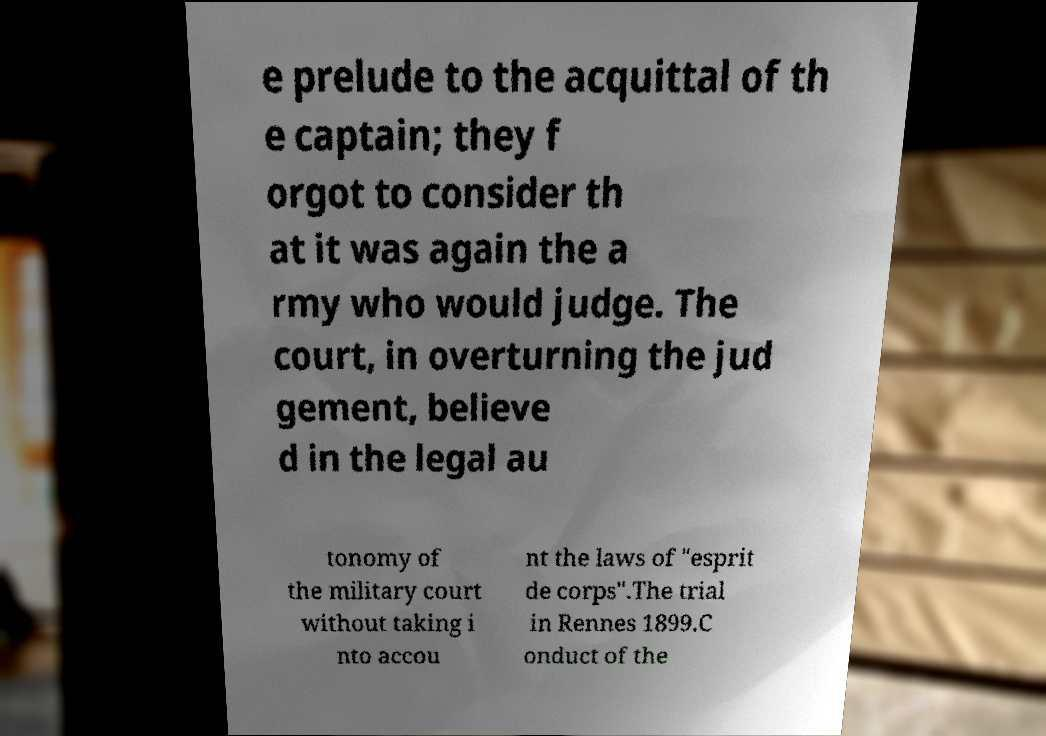Can you read and provide the text displayed in the image?This photo seems to have some interesting text. Can you extract and type it out for me? e prelude to the acquittal of th e captain; they f orgot to consider th at it was again the a rmy who would judge. The court, in overturning the jud gement, believe d in the legal au tonomy of the military court without taking i nto accou nt the laws of "esprit de corps".The trial in Rennes 1899.C onduct of the 